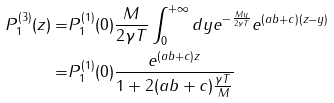<formula> <loc_0><loc_0><loc_500><loc_500>P ^ { ( 3 ) } _ { 1 } ( z ) = & P ^ { ( 1 ) } _ { 1 } ( 0 ) \frac { M } { 2 \gamma T } \int _ { 0 } ^ { + \infty } d y e ^ { - \frac { M y } { 2 \gamma T } } e ^ { ( a b + c ) ( z - y ) } \\ = & P ^ { ( 1 ) } _ { 1 } ( 0 ) \frac { e ^ { ( a b + c ) z } } { 1 + 2 ( a b + c ) \frac { \gamma T } { M } }</formula> 